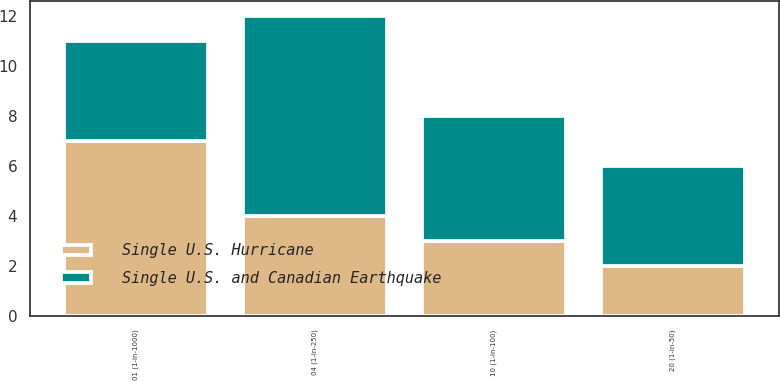<chart> <loc_0><loc_0><loc_500><loc_500><stacked_bar_chart><ecel><fcel>20 (1-in-50)<fcel>10 (1-in-100)<fcel>04 (1-in-250)<fcel>01 (1-in-1000)<nl><fcel>Single U.S. and Canadian Earthquake<fcel>4<fcel>5<fcel>8<fcel>4<nl><fcel>Single U.S. Hurricane<fcel>2<fcel>3<fcel>4<fcel>7<nl></chart> 